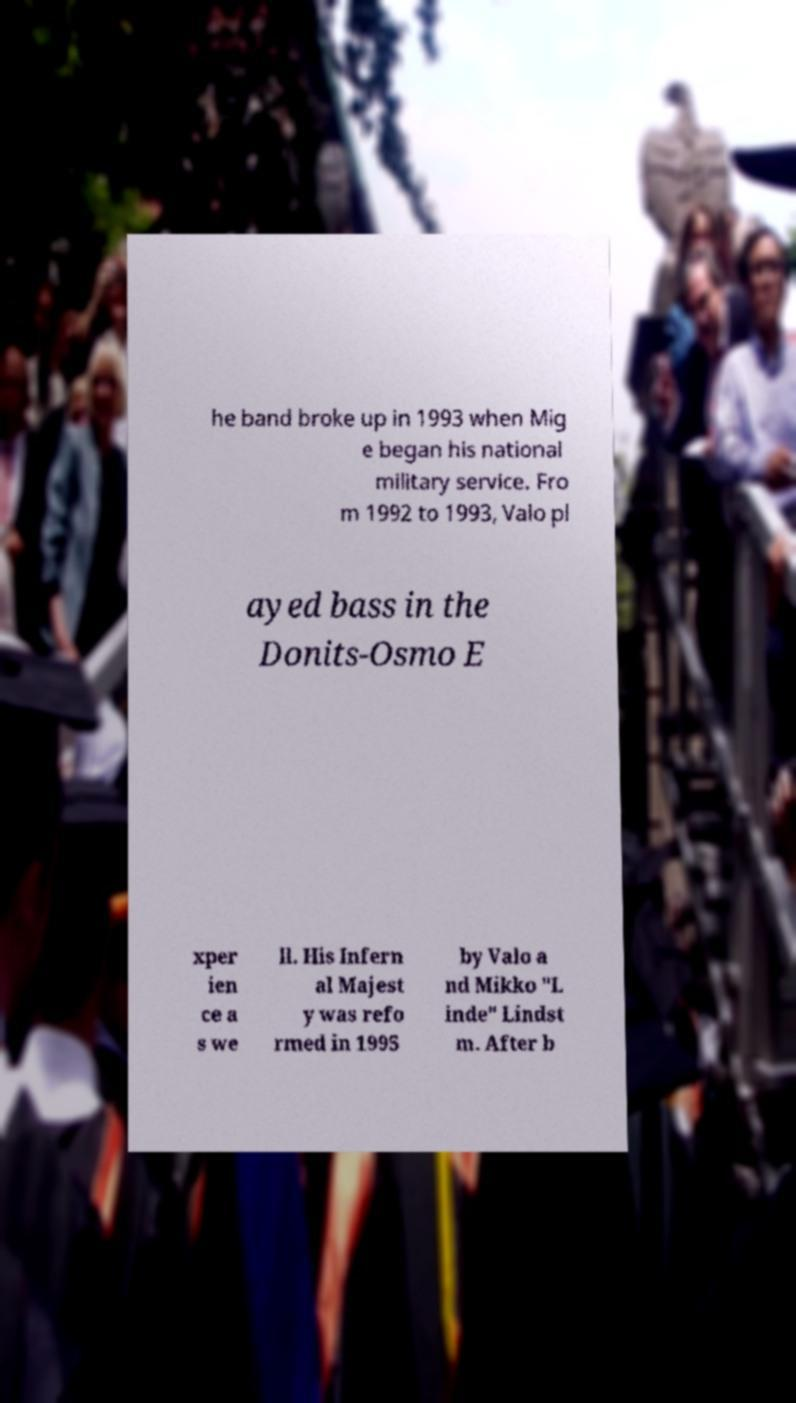Could you assist in decoding the text presented in this image and type it out clearly? he band broke up in 1993 when Mig e began his national military service. Fro m 1992 to 1993, Valo pl ayed bass in the Donits-Osmo E xper ien ce a s we ll. His Infern al Majest y was refo rmed in 1995 by Valo a nd Mikko "L inde" Lindst m. After b 